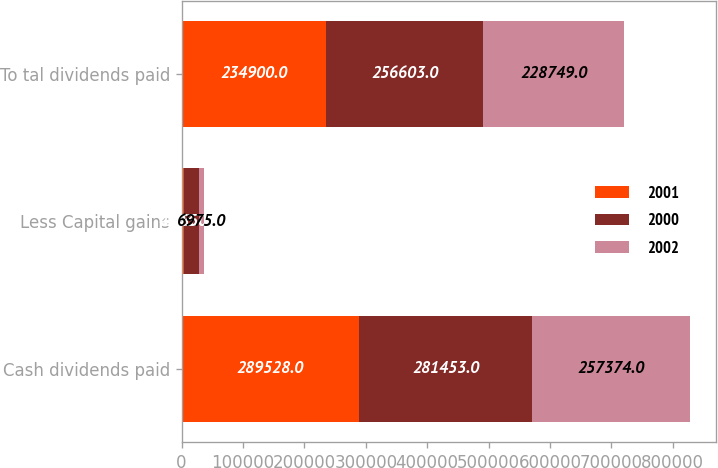Convert chart to OTSL. <chart><loc_0><loc_0><loc_500><loc_500><stacked_bar_chart><ecel><fcel>Cash dividends paid<fcel>Less Capital gains<fcel>To tal dividends paid<nl><fcel>2001<fcel>289528<fcel>4203<fcel>234900<nl><fcel>2000<fcel>281453<fcel>24850<fcel>256603<nl><fcel>2002<fcel>257374<fcel>6975<fcel>228749<nl></chart> 